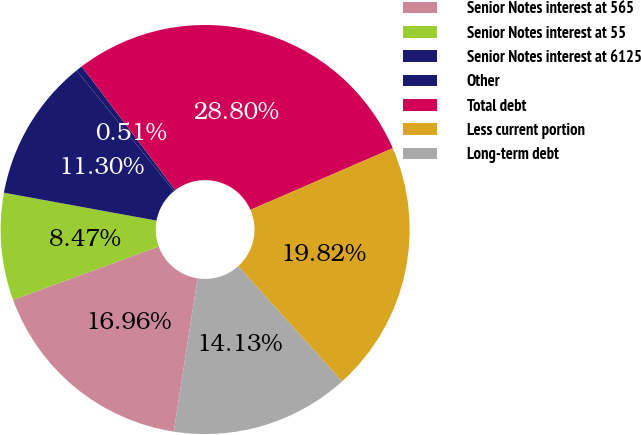Convert chart. <chart><loc_0><loc_0><loc_500><loc_500><pie_chart><fcel>Senior Notes interest at 565<fcel>Senior Notes interest at 55<fcel>Senior Notes interest at 6125<fcel>Other<fcel>Total debt<fcel>Less current portion<fcel>Long-term debt<nl><fcel>16.96%<fcel>8.47%<fcel>11.3%<fcel>0.51%<fcel>28.8%<fcel>19.82%<fcel>14.13%<nl></chart> 